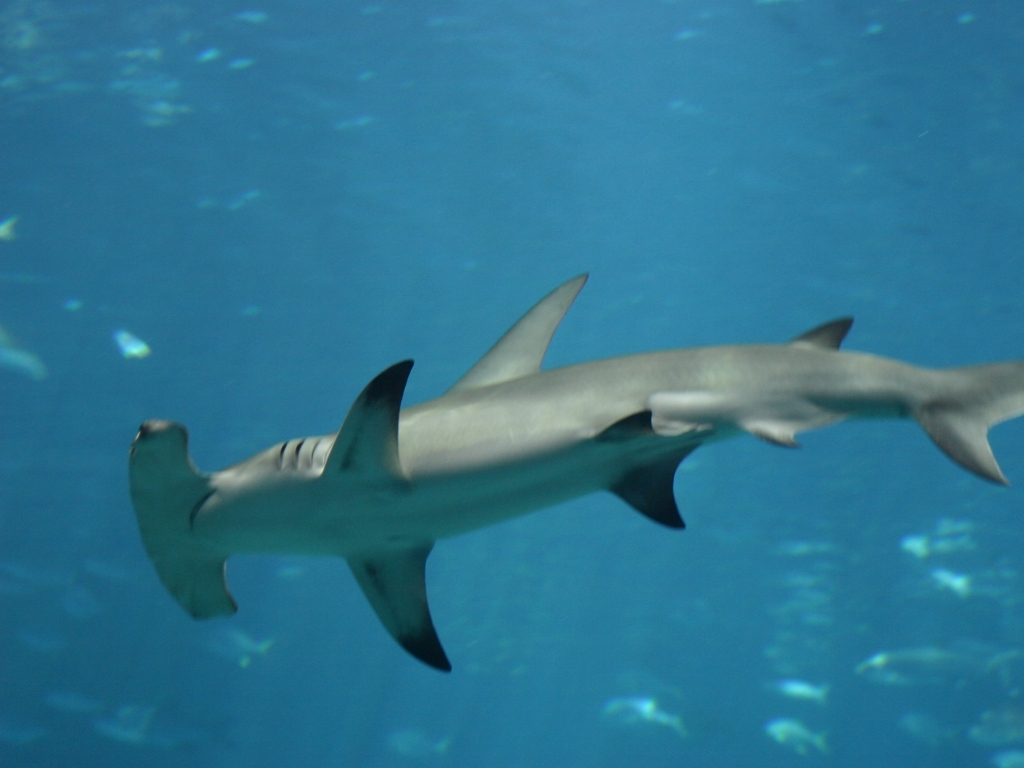What might be the reasons for the blurriness in the image? The blurriness in the image can be attributed to several factors, such as the movement of the shark or the photographer's motion, the lighting conditions underwater which are often less than ideal, the presence of particulate matter in the water, or limitations of the camera's focus in capturing fast-moving subjects. In underwater photography, achieving perfect clarity can be quite challenging. 